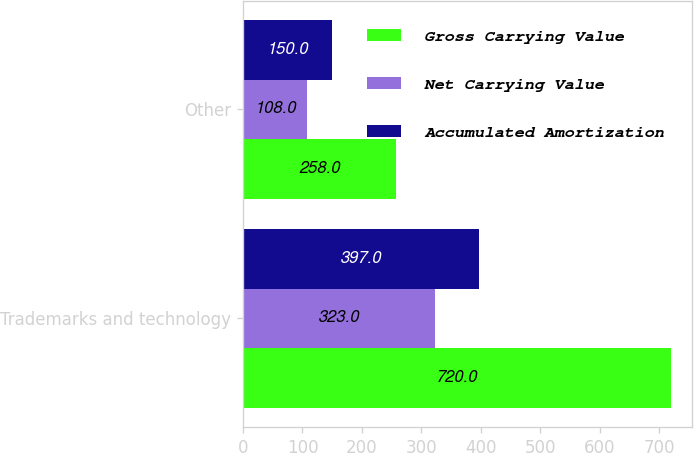Convert chart. <chart><loc_0><loc_0><loc_500><loc_500><stacked_bar_chart><ecel><fcel>Trademarks and technology<fcel>Other<nl><fcel>Gross Carrying Value<fcel>720<fcel>258<nl><fcel>Net Carrying Value<fcel>323<fcel>108<nl><fcel>Accumulated Amortization<fcel>397<fcel>150<nl></chart> 